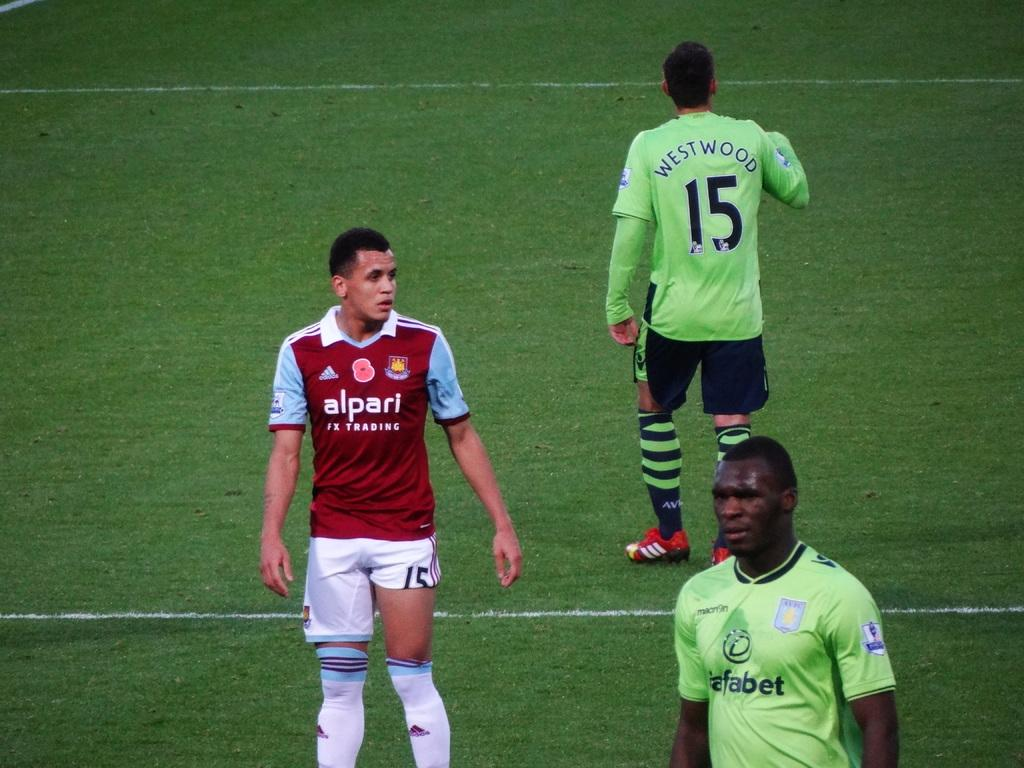How many people are in the image? There is a group of people in the image, but the exact number is not specified. What is the position of the people in the image? The people are standing on the ground in the image. What type of car can be seen in the background of the image? There is no car present in the image; it only features a group of people standing on the ground. 